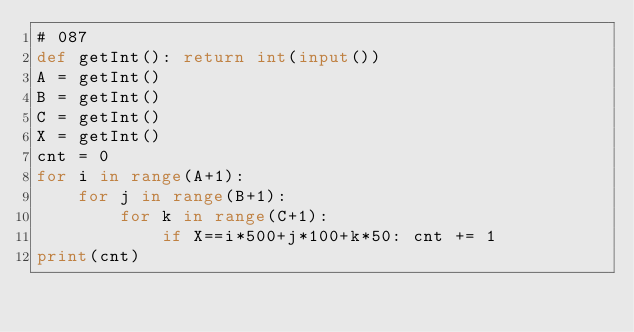<code> <loc_0><loc_0><loc_500><loc_500><_Python_># 087
def getInt(): return int(input())
A = getInt()
B = getInt()
C = getInt()
X = getInt()
cnt = 0
for i in range(A+1):
    for j in range(B+1):
        for k in range(C+1):
            if X==i*500+j*100+k*50: cnt += 1
print(cnt)</code> 